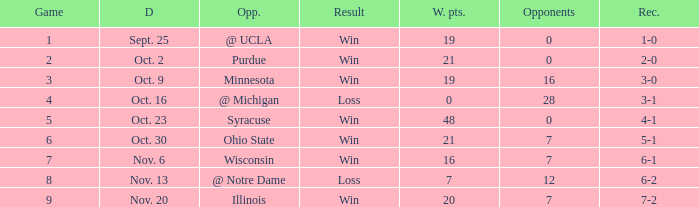What game number did the Wildcats play Purdue? 2.0. 